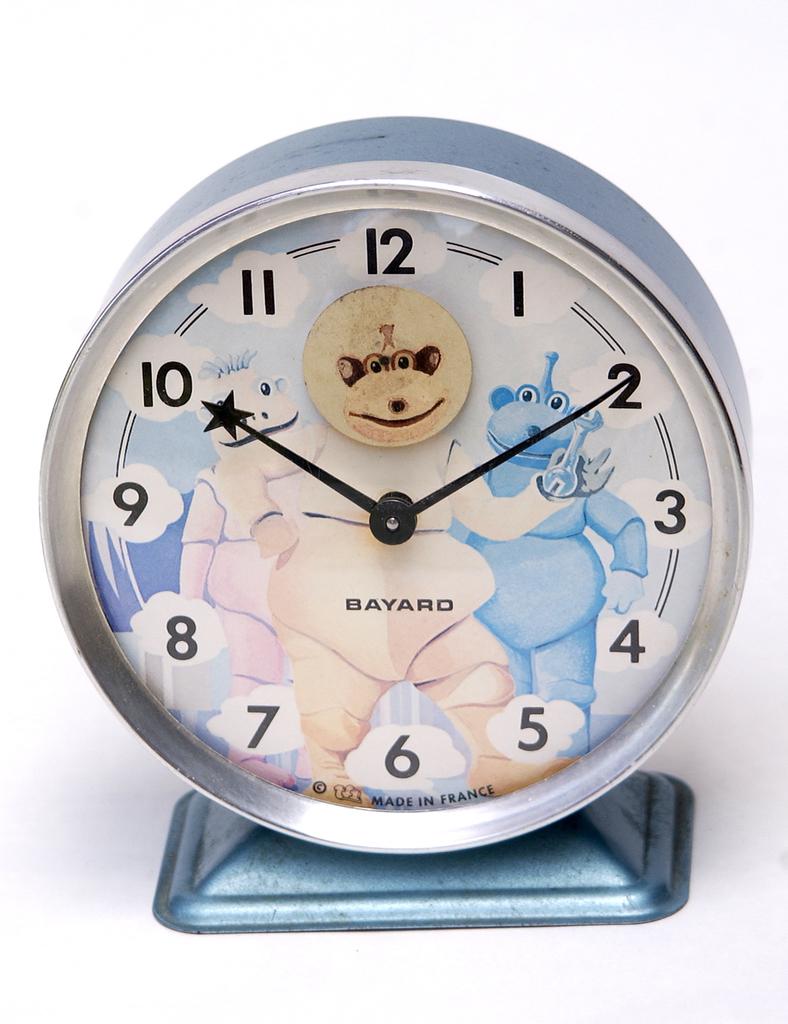What brand is the clock?
Your answer should be compact. Bayard. What time is it?
Provide a short and direct response. 10:10. 